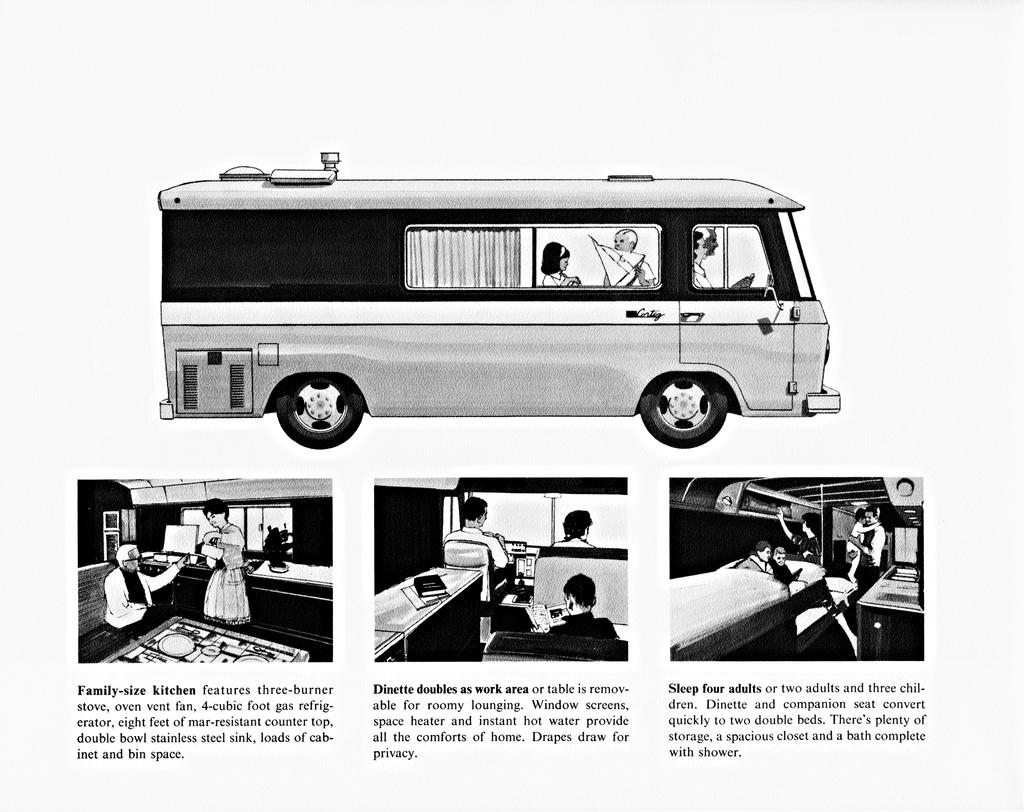<image>
Write a terse but informative summary of the picture. An advertisement for a camper bus with a family size kitchen and it sleeps four people. 